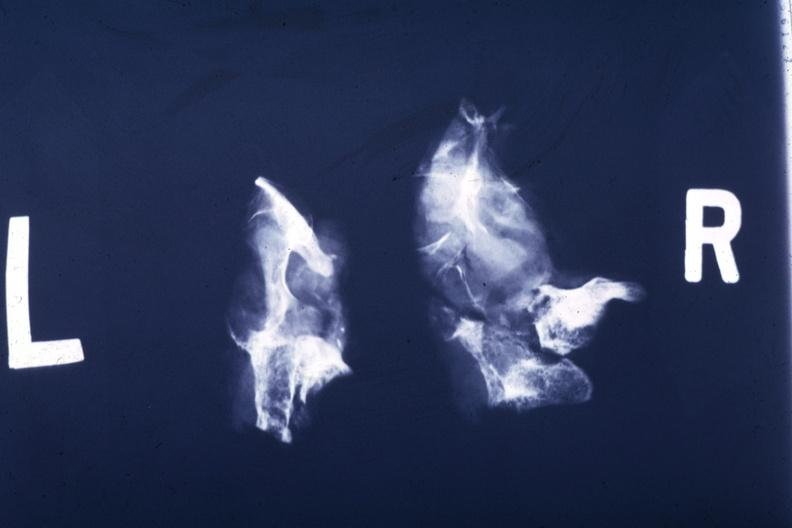s coronary atherosclerosis present?
Answer the question using a single word or phrase. No 